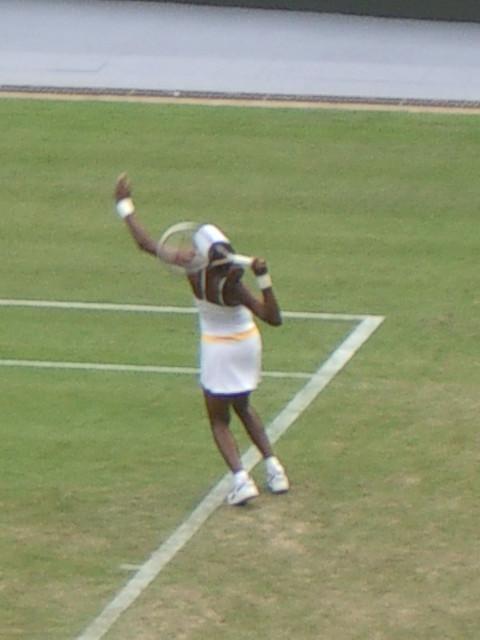How many people are in the picture?
Give a very brief answer. 1. 